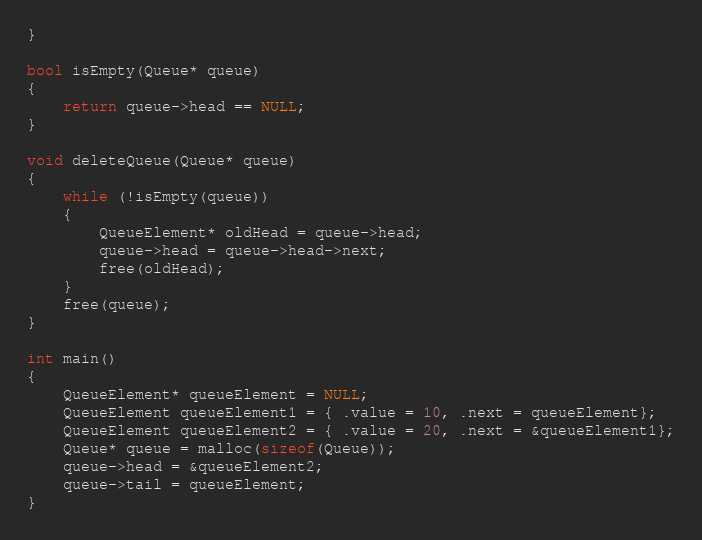<code> <loc_0><loc_0><loc_500><loc_500><_C_>}

bool isEmpty(Queue* queue)
{
    return queue->head == NULL;
}

void deleteQueue(Queue* queue)
{
    while (!isEmpty(queue))
    {
        QueueElement* oldHead = queue->head;
        queue->head = queue->head->next;
        free(oldHead);
    }
    free(queue);
}

int main()
{
    QueueElement* queueElement = NULL;
    QueueElement queueElement1 = { .value = 10, .next = queueElement};
    QueueElement queueElement2 = { .value = 20, .next = &queueElement1};
    Queue* queue = malloc(sizeof(Queue));
    queue->head = &queueElement2;
    queue->tail = queueElement;
}</code> 